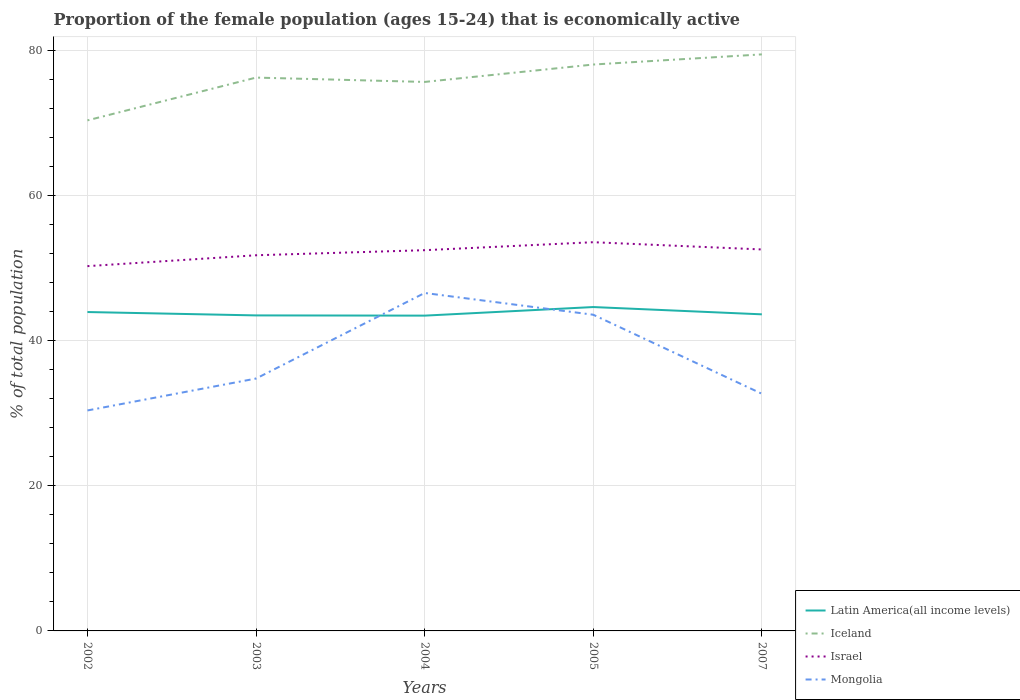How many different coloured lines are there?
Provide a short and direct response. 4. Across all years, what is the maximum proportion of the female population that is economically active in Mongolia?
Your answer should be compact. 30.4. What is the total proportion of the female population that is economically active in Israel in the graph?
Your answer should be compact. -0.1. What is the difference between the highest and the second highest proportion of the female population that is economically active in Israel?
Your answer should be very brief. 3.3. What is the difference between two consecutive major ticks on the Y-axis?
Provide a short and direct response. 20. Are the values on the major ticks of Y-axis written in scientific E-notation?
Ensure brevity in your answer.  No. How many legend labels are there?
Ensure brevity in your answer.  4. What is the title of the graph?
Give a very brief answer. Proportion of the female population (ages 15-24) that is economically active. What is the label or title of the X-axis?
Your answer should be compact. Years. What is the label or title of the Y-axis?
Ensure brevity in your answer.  % of total population. What is the % of total population in Latin America(all income levels) in 2002?
Give a very brief answer. 43.97. What is the % of total population in Iceland in 2002?
Give a very brief answer. 70.4. What is the % of total population in Israel in 2002?
Provide a succinct answer. 50.3. What is the % of total population of Mongolia in 2002?
Keep it short and to the point. 30.4. What is the % of total population of Latin America(all income levels) in 2003?
Make the answer very short. 43.51. What is the % of total population of Iceland in 2003?
Provide a succinct answer. 76.3. What is the % of total population in Israel in 2003?
Give a very brief answer. 51.8. What is the % of total population of Mongolia in 2003?
Provide a short and direct response. 34.8. What is the % of total population in Latin America(all income levels) in 2004?
Offer a very short reply. 43.48. What is the % of total population in Iceland in 2004?
Your answer should be very brief. 75.7. What is the % of total population in Israel in 2004?
Your answer should be very brief. 52.5. What is the % of total population in Mongolia in 2004?
Make the answer very short. 46.6. What is the % of total population of Latin America(all income levels) in 2005?
Offer a terse response. 44.66. What is the % of total population of Iceland in 2005?
Keep it short and to the point. 78.1. What is the % of total population in Israel in 2005?
Offer a very short reply. 53.6. What is the % of total population of Mongolia in 2005?
Your answer should be very brief. 43.6. What is the % of total population of Latin America(all income levels) in 2007?
Your answer should be compact. 43.65. What is the % of total population of Iceland in 2007?
Your answer should be very brief. 79.5. What is the % of total population in Israel in 2007?
Your response must be concise. 52.6. What is the % of total population of Mongolia in 2007?
Keep it short and to the point. 32.7. Across all years, what is the maximum % of total population of Latin America(all income levels)?
Make the answer very short. 44.66. Across all years, what is the maximum % of total population of Iceland?
Offer a very short reply. 79.5. Across all years, what is the maximum % of total population in Israel?
Give a very brief answer. 53.6. Across all years, what is the maximum % of total population in Mongolia?
Offer a terse response. 46.6. Across all years, what is the minimum % of total population of Latin America(all income levels)?
Your answer should be very brief. 43.48. Across all years, what is the minimum % of total population in Iceland?
Your answer should be very brief. 70.4. Across all years, what is the minimum % of total population of Israel?
Make the answer very short. 50.3. Across all years, what is the minimum % of total population of Mongolia?
Give a very brief answer. 30.4. What is the total % of total population of Latin America(all income levels) in the graph?
Give a very brief answer. 219.27. What is the total % of total population of Iceland in the graph?
Your response must be concise. 380. What is the total % of total population of Israel in the graph?
Ensure brevity in your answer.  260.8. What is the total % of total population of Mongolia in the graph?
Keep it short and to the point. 188.1. What is the difference between the % of total population of Latin America(all income levels) in 2002 and that in 2003?
Your answer should be very brief. 0.46. What is the difference between the % of total population of Iceland in 2002 and that in 2003?
Your answer should be compact. -5.9. What is the difference between the % of total population of Latin America(all income levels) in 2002 and that in 2004?
Keep it short and to the point. 0.5. What is the difference between the % of total population of Mongolia in 2002 and that in 2004?
Keep it short and to the point. -16.2. What is the difference between the % of total population in Latin America(all income levels) in 2002 and that in 2005?
Keep it short and to the point. -0.69. What is the difference between the % of total population of Iceland in 2002 and that in 2005?
Give a very brief answer. -7.7. What is the difference between the % of total population of Mongolia in 2002 and that in 2005?
Provide a short and direct response. -13.2. What is the difference between the % of total population in Latin America(all income levels) in 2002 and that in 2007?
Offer a very short reply. 0.32. What is the difference between the % of total population of Iceland in 2002 and that in 2007?
Provide a succinct answer. -9.1. What is the difference between the % of total population in Latin America(all income levels) in 2003 and that in 2004?
Keep it short and to the point. 0.03. What is the difference between the % of total population of Israel in 2003 and that in 2004?
Keep it short and to the point. -0.7. What is the difference between the % of total population in Mongolia in 2003 and that in 2004?
Your answer should be very brief. -11.8. What is the difference between the % of total population in Latin America(all income levels) in 2003 and that in 2005?
Provide a succinct answer. -1.15. What is the difference between the % of total population in Latin America(all income levels) in 2003 and that in 2007?
Offer a terse response. -0.15. What is the difference between the % of total population of Iceland in 2003 and that in 2007?
Your response must be concise. -3.2. What is the difference between the % of total population in Latin America(all income levels) in 2004 and that in 2005?
Keep it short and to the point. -1.18. What is the difference between the % of total population in Latin America(all income levels) in 2004 and that in 2007?
Provide a succinct answer. -0.18. What is the difference between the % of total population in Israel in 2004 and that in 2007?
Offer a terse response. -0.1. What is the difference between the % of total population in Israel in 2005 and that in 2007?
Provide a succinct answer. 1. What is the difference between the % of total population in Latin America(all income levels) in 2002 and the % of total population in Iceland in 2003?
Your response must be concise. -32.33. What is the difference between the % of total population of Latin America(all income levels) in 2002 and the % of total population of Israel in 2003?
Ensure brevity in your answer.  -7.83. What is the difference between the % of total population of Latin America(all income levels) in 2002 and the % of total population of Mongolia in 2003?
Offer a terse response. 9.17. What is the difference between the % of total population in Iceland in 2002 and the % of total population in Mongolia in 2003?
Keep it short and to the point. 35.6. What is the difference between the % of total population of Latin America(all income levels) in 2002 and the % of total population of Iceland in 2004?
Give a very brief answer. -31.73. What is the difference between the % of total population of Latin America(all income levels) in 2002 and the % of total population of Israel in 2004?
Your answer should be compact. -8.53. What is the difference between the % of total population in Latin America(all income levels) in 2002 and the % of total population in Mongolia in 2004?
Your answer should be compact. -2.63. What is the difference between the % of total population of Iceland in 2002 and the % of total population of Israel in 2004?
Make the answer very short. 17.9. What is the difference between the % of total population of Iceland in 2002 and the % of total population of Mongolia in 2004?
Provide a succinct answer. 23.8. What is the difference between the % of total population of Israel in 2002 and the % of total population of Mongolia in 2004?
Your response must be concise. 3.7. What is the difference between the % of total population of Latin America(all income levels) in 2002 and the % of total population of Iceland in 2005?
Ensure brevity in your answer.  -34.13. What is the difference between the % of total population of Latin America(all income levels) in 2002 and the % of total population of Israel in 2005?
Provide a succinct answer. -9.63. What is the difference between the % of total population in Latin America(all income levels) in 2002 and the % of total population in Mongolia in 2005?
Your answer should be compact. 0.37. What is the difference between the % of total population in Iceland in 2002 and the % of total population in Israel in 2005?
Make the answer very short. 16.8. What is the difference between the % of total population of Iceland in 2002 and the % of total population of Mongolia in 2005?
Offer a terse response. 26.8. What is the difference between the % of total population in Israel in 2002 and the % of total population in Mongolia in 2005?
Keep it short and to the point. 6.7. What is the difference between the % of total population of Latin America(all income levels) in 2002 and the % of total population of Iceland in 2007?
Keep it short and to the point. -35.53. What is the difference between the % of total population in Latin America(all income levels) in 2002 and the % of total population in Israel in 2007?
Give a very brief answer. -8.63. What is the difference between the % of total population in Latin America(all income levels) in 2002 and the % of total population in Mongolia in 2007?
Ensure brevity in your answer.  11.27. What is the difference between the % of total population of Iceland in 2002 and the % of total population of Israel in 2007?
Make the answer very short. 17.8. What is the difference between the % of total population in Iceland in 2002 and the % of total population in Mongolia in 2007?
Your answer should be very brief. 37.7. What is the difference between the % of total population in Latin America(all income levels) in 2003 and the % of total population in Iceland in 2004?
Your answer should be compact. -32.19. What is the difference between the % of total population of Latin America(all income levels) in 2003 and the % of total population of Israel in 2004?
Ensure brevity in your answer.  -8.99. What is the difference between the % of total population in Latin America(all income levels) in 2003 and the % of total population in Mongolia in 2004?
Your answer should be compact. -3.09. What is the difference between the % of total population of Iceland in 2003 and the % of total population of Israel in 2004?
Your response must be concise. 23.8. What is the difference between the % of total population in Iceland in 2003 and the % of total population in Mongolia in 2004?
Offer a very short reply. 29.7. What is the difference between the % of total population of Israel in 2003 and the % of total population of Mongolia in 2004?
Your response must be concise. 5.2. What is the difference between the % of total population in Latin America(all income levels) in 2003 and the % of total population in Iceland in 2005?
Your answer should be very brief. -34.59. What is the difference between the % of total population of Latin America(all income levels) in 2003 and the % of total population of Israel in 2005?
Offer a terse response. -10.09. What is the difference between the % of total population of Latin America(all income levels) in 2003 and the % of total population of Mongolia in 2005?
Offer a very short reply. -0.09. What is the difference between the % of total population of Iceland in 2003 and the % of total population of Israel in 2005?
Make the answer very short. 22.7. What is the difference between the % of total population of Iceland in 2003 and the % of total population of Mongolia in 2005?
Offer a very short reply. 32.7. What is the difference between the % of total population in Israel in 2003 and the % of total population in Mongolia in 2005?
Provide a succinct answer. 8.2. What is the difference between the % of total population of Latin America(all income levels) in 2003 and the % of total population of Iceland in 2007?
Your response must be concise. -35.99. What is the difference between the % of total population in Latin America(all income levels) in 2003 and the % of total population in Israel in 2007?
Offer a terse response. -9.09. What is the difference between the % of total population in Latin America(all income levels) in 2003 and the % of total population in Mongolia in 2007?
Provide a succinct answer. 10.81. What is the difference between the % of total population of Iceland in 2003 and the % of total population of Israel in 2007?
Offer a terse response. 23.7. What is the difference between the % of total population of Iceland in 2003 and the % of total population of Mongolia in 2007?
Your answer should be compact. 43.6. What is the difference between the % of total population in Latin America(all income levels) in 2004 and the % of total population in Iceland in 2005?
Offer a terse response. -34.62. What is the difference between the % of total population in Latin America(all income levels) in 2004 and the % of total population in Israel in 2005?
Provide a short and direct response. -10.12. What is the difference between the % of total population of Latin America(all income levels) in 2004 and the % of total population of Mongolia in 2005?
Ensure brevity in your answer.  -0.12. What is the difference between the % of total population of Iceland in 2004 and the % of total population of Israel in 2005?
Your response must be concise. 22.1. What is the difference between the % of total population of Iceland in 2004 and the % of total population of Mongolia in 2005?
Your answer should be very brief. 32.1. What is the difference between the % of total population in Latin America(all income levels) in 2004 and the % of total population in Iceland in 2007?
Offer a very short reply. -36.02. What is the difference between the % of total population of Latin America(all income levels) in 2004 and the % of total population of Israel in 2007?
Make the answer very short. -9.12. What is the difference between the % of total population in Latin America(all income levels) in 2004 and the % of total population in Mongolia in 2007?
Your answer should be compact. 10.78. What is the difference between the % of total population in Iceland in 2004 and the % of total population in Israel in 2007?
Ensure brevity in your answer.  23.1. What is the difference between the % of total population in Israel in 2004 and the % of total population in Mongolia in 2007?
Keep it short and to the point. 19.8. What is the difference between the % of total population of Latin America(all income levels) in 2005 and the % of total population of Iceland in 2007?
Your response must be concise. -34.84. What is the difference between the % of total population of Latin America(all income levels) in 2005 and the % of total population of Israel in 2007?
Provide a succinct answer. -7.94. What is the difference between the % of total population of Latin America(all income levels) in 2005 and the % of total population of Mongolia in 2007?
Make the answer very short. 11.96. What is the difference between the % of total population of Iceland in 2005 and the % of total population of Mongolia in 2007?
Ensure brevity in your answer.  45.4. What is the difference between the % of total population in Israel in 2005 and the % of total population in Mongolia in 2007?
Your response must be concise. 20.9. What is the average % of total population in Latin America(all income levels) per year?
Keep it short and to the point. 43.85. What is the average % of total population of Iceland per year?
Offer a very short reply. 76. What is the average % of total population of Israel per year?
Ensure brevity in your answer.  52.16. What is the average % of total population in Mongolia per year?
Keep it short and to the point. 37.62. In the year 2002, what is the difference between the % of total population of Latin America(all income levels) and % of total population of Iceland?
Offer a very short reply. -26.43. In the year 2002, what is the difference between the % of total population in Latin America(all income levels) and % of total population in Israel?
Give a very brief answer. -6.33. In the year 2002, what is the difference between the % of total population in Latin America(all income levels) and % of total population in Mongolia?
Ensure brevity in your answer.  13.57. In the year 2002, what is the difference between the % of total population in Iceland and % of total population in Israel?
Offer a very short reply. 20.1. In the year 2003, what is the difference between the % of total population in Latin America(all income levels) and % of total population in Iceland?
Provide a short and direct response. -32.79. In the year 2003, what is the difference between the % of total population of Latin America(all income levels) and % of total population of Israel?
Your answer should be very brief. -8.29. In the year 2003, what is the difference between the % of total population in Latin America(all income levels) and % of total population in Mongolia?
Offer a terse response. 8.71. In the year 2003, what is the difference between the % of total population of Iceland and % of total population of Israel?
Offer a very short reply. 24.5. In the year 2003, what is the difference between the % of total population in Iceland and % of total population in Mongolia?
Provide a short and direct response. 41.5. In the year 2003, what is the difference between the % of total population of Israel and % of total population of Mongolia?
Offer a very short reply. 17. In the year 2004, what is the difference between the % of total population of Latin America(all income levels) and % of total population of Iceland?
Ensure brevity in your answer.  -32.22. In the year 2004, what is the difference between the % of total population of Latin America(all income levels) and % of total population of Israel?
Give a very brief answer. -9.02. In the year 2004, what is the difference between the % of total population of Latin America(all income levels) and % of total population of Mongolia?
Your answer should be very brief. -3.12. In the year 2004, what is the difference between the % of total population in Iceland and % of total population in Israel?
Provide a short and direct response. 23.2. In the year 2004, what is the difference between the % of total population of Iceland and % of total population of Mongolia?
Provide a short and direct response. 29.1. In the year 2005, what is the difference between the % of total population in Latin America(all income levels) and % of total population in Iceland?
Offer a terse response. -33.44. In the year 2005, what is the difference between the % of total population in Latin America(all income levels) and % of total population in Israel?
Offer a terse response. -8.94. In the year 2005, what is the difference between the % of total population in Latin America(all income levels) and % of total population in Mongolia?
Your response must be concise. 1.06. In the year 2005, what is the difference between the % of total population in Iceland and % of total population in Israel?
Provide a succinct answer. 24.5. In the year 2005, what is the difference between the % of total population in Iceland and % of total population in Mongolia?
Ensure brevity in your answer.  34.5. In the year 2005, what is the difference between the % of total population in Israel and % of total population in Mongolia?
Ensure brevity in your answer.  10. In the year 2007, what is the difference between the % of total population in Latin America(all income levels) and % of total population in Iceland?
Ensure brevity in your answer.  -35.85. In the year 2007, what is the difference between the % of total population in Latin America(all income levels) and % of total population in Israel?
Your response must be concise. -8.95. In the year 2007, what is the difference between the % of total population in Latin America(all income levels) and % of total population in Mongolia?
Give a very brief answer. 10.95. In the year 2007, what is the difference between the % of total population in Iceland and % of total population in Israel?
Give a very brief answer. 26.9. In the year 2007, what is the difference between the % of total population in Iceland and % of total population in Mongolia?
Give a very brief answer. 46.8. What is the ratio of the % of total population in Latin America(all income levels) in 2002 to that in 2003?
Offer a very short reply. 1.01. What is the ratio of the % of total population in Iceland in 2002 to that in 2003?
Offer a terse response. 0.92. What is the ratio of the % of total population of Israel in 2002 to that in 2003?
Ensure brevity in your answer.  0.97. What is the ratio of the % of total population in Mongolia in 2002 to that in 2003?
Your answer should be very brief. 0.87. What is the ratio of the % of total population in Latin America(all income levels) in 2002 to that in 2004?
Ensure brevity in your answer.  1.01. What is the ratio of the % of total population in Israel in 2002 to that in 2004?
Keep it short and to the point. 0.96. What is the ratio of the % of total population of Mongolia in 2002 to that in 2004?
Your answer should be compact. 0.65. What is the ratio of the % of total population of Latin America(all income levels) in 2002 to that in 2005?
Offer a very short reply. 0.98. What is the ratio of the % of total population of Iceland in 2002 to that in 2005?
Provide a short and direct response. 0.9. What is the ratio of the % of total population in Israel in 2002 to that in 2005?
Offer a very short reply. 0.94. What is the ratio of the % of total population in Mongolia in 2002 to that in 2005?
Provide a short and direct response. 0.7. What is the ratio of the % of total population in Latin America(all income levels) in 2002 to that in 2007?
Ensure brevity in your answer.  1.01. What is the ratio of the % of total population in Iceland in 2002 to that in 2007?
Your response must be concise. 0.89. What is the ratio of the % of total population in Israel in 2002 to that in 2007?
Provide a short and direct response. 0.96. What is the ratio of the % of total population of Mongolia in 2002 to that in 2007?
Provide a short and direct response. 0.93. What is the ratio of the % of total population of Iceland in 2003 to that in 2004?
Your response must be concise. 1.01. What is the ratio of the % of total population of Israel in 2003 to that in 2004?
Provide a short and direct response. 0.99. What is the ratio of the % of total population of Mongolia in 2003 to that in 2004?
Give a very brief answer. 0.75. What is the ratio of the % of total population in Latin America(all income levels) in 2003 to that in 2005?
Your answer should be very brief. 0.97. What is the ratio of the % of total population in Israel in 2003 to that in 2005?
Make the answer very short. 0.97. What is the ratio of the % of total population of Mongolia in 2003 to that in 2005?
Your answer should be very brief. 0.8. What is the ratio of the % of total population of Latin America(all income levels) in 2003 to that in 2007?
Offer a terse response. 1. What is the ratio of the % of total population in Iceland in 2003 to that in 2007?
Offer a terse response. 0.96. What is the ratio of the % of total population of Israel in 2003 to that in 2007?
Your answer should be very brief. 0.98. What is the ratio of the % of total population of Mongolia in 2003 to that in 2007?
Make the answer very short. 1.06. What is the ratio of the % of total population of Latin America(all income levels) in 2004 to that in 2005?
Make the answer very short. 0.97. What is the ratio of the % of total population in Iceland in 2004 to that in 2005?
Your answer should be very brief. 0.97. What is the ratio of the % of total population of Israel in 2004 to that in 2005?
Your response must be concise. 0.98. What is the ratio of the % of total population in Mongolia in 2004 to that in 2005?
Ensure brevity in your answer.  1.07. What is the ratio of the % of total population in Latin America(all income levels) in 2004 to that in 2007?
Keep it short and to the point. 1. What is the ratio of the % of total population in Iceland in 2004 to that in 2007?
Offer a very short reply. 0.95. What is the ratio of the % of total population of Israel in 2004 to that in 2007?
Ensure brevity in your answer.  1. What is the ratio of the % of total population of Mongolia in 2004 to that in 2007?
Make the answer very short. 1.43. What is the ratio of the % of total population of Iceland in 2005 to that in 2007?
Ensure brevity in your answer.  0.98. What is the difference between the highest and the second highest % of total population of Latin America(all income levels)?
Give a very brief answer. 0.69. What is the difference between the highest and the second highest % of total population of Iceland?
Offer a very short reply. 1.4. What is the difference between the highest and the second highest % of total population in Israel?
Keep it short and to the point. 1. What is the difference between the highest and the lowest % of total population in Latin America(all income levels)?
Ensure brevity in your answer.  1.18. What is the difference between the highest and the lowest % of total population of Israel?
Give a very brief answer. 3.3. What is the difference between the highest and the lowest % of total population in Mongolia?
Your answer should be very brief. 16.2. 